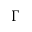<formula> <loc_0><loc_0><loc_500><loc_500>\Gamma</formula> 